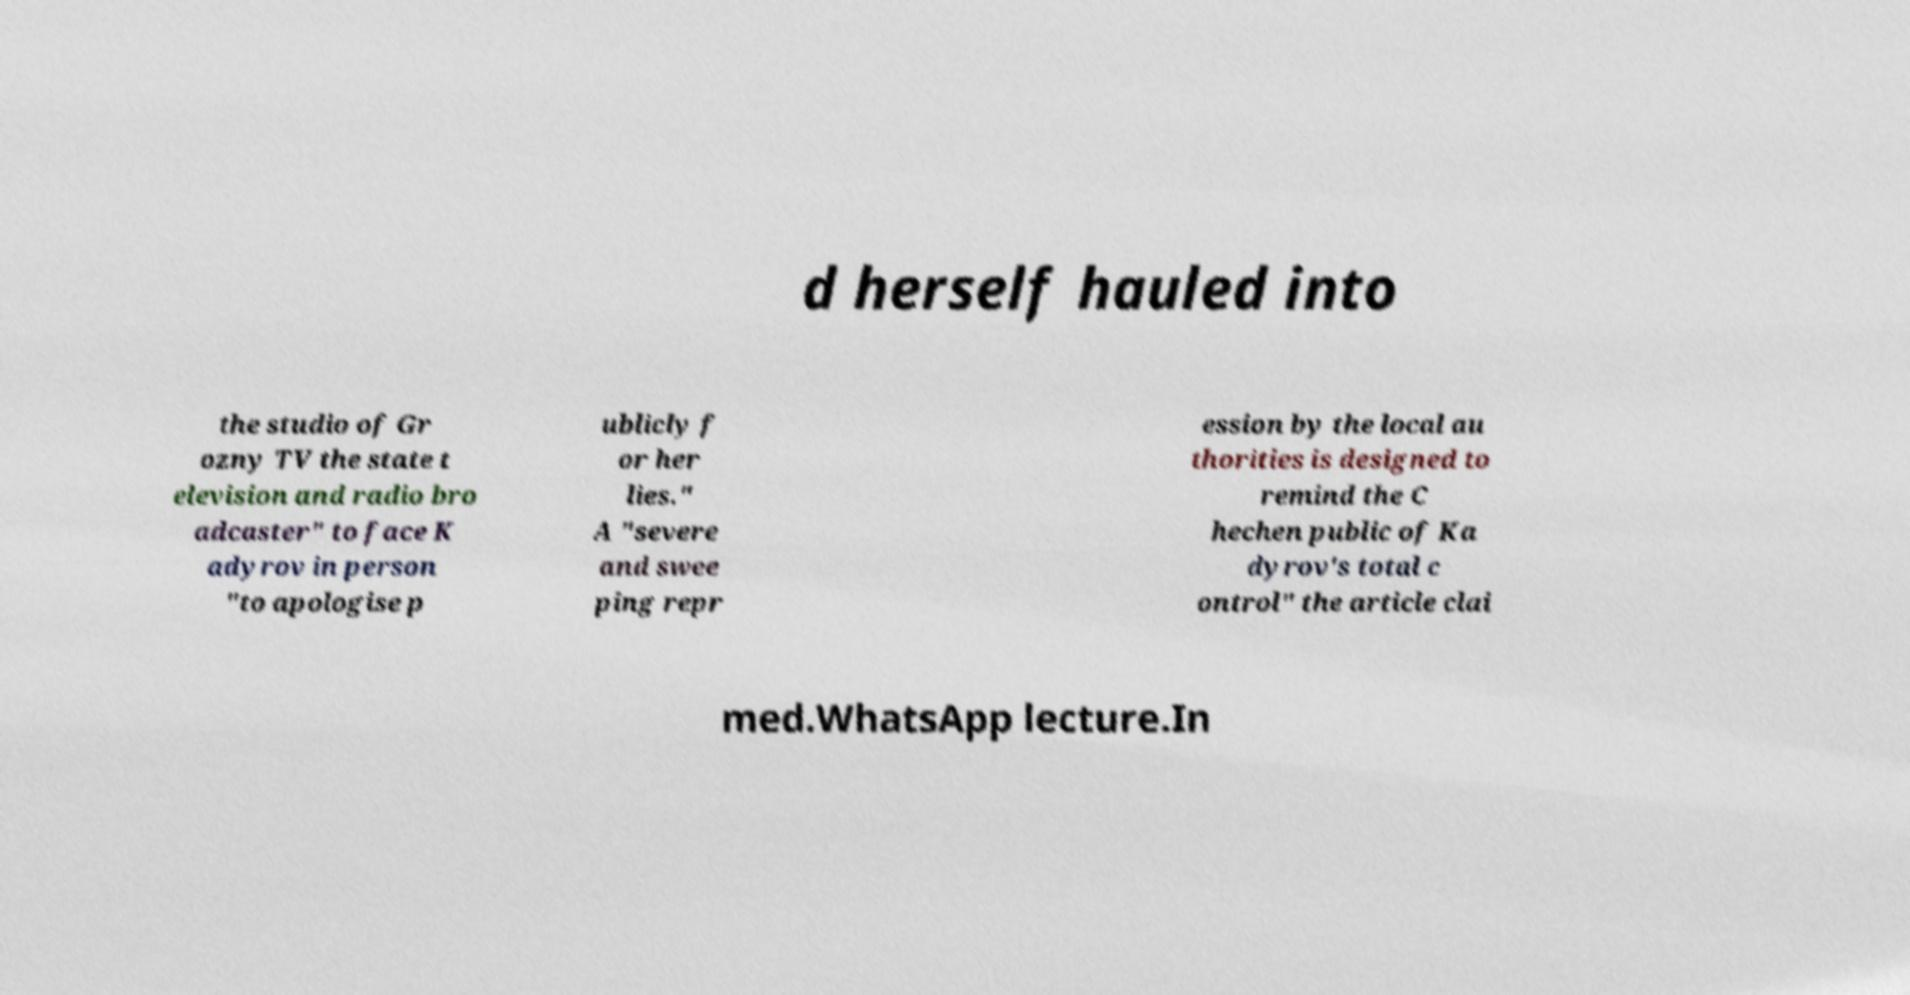I need the written content from this picture converted into text. Can you do that? d herself hauled into the studio of Gr ozny TV the state t elevision and radio bro adcaster" to face K adyrov in person "to apologise p ublicly f or her lies." A "severe and swee ping repr ession by the local au thorities is designed to remind the C hechen public of Ka dyrov's total c ontrol" the article clai med.WhatsApp lecture.In 